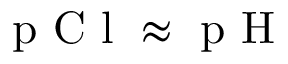Convert formula to latex. <formula><loc_0><loc_0><loc_500><loc_500>p C l \approx p H</formula> 